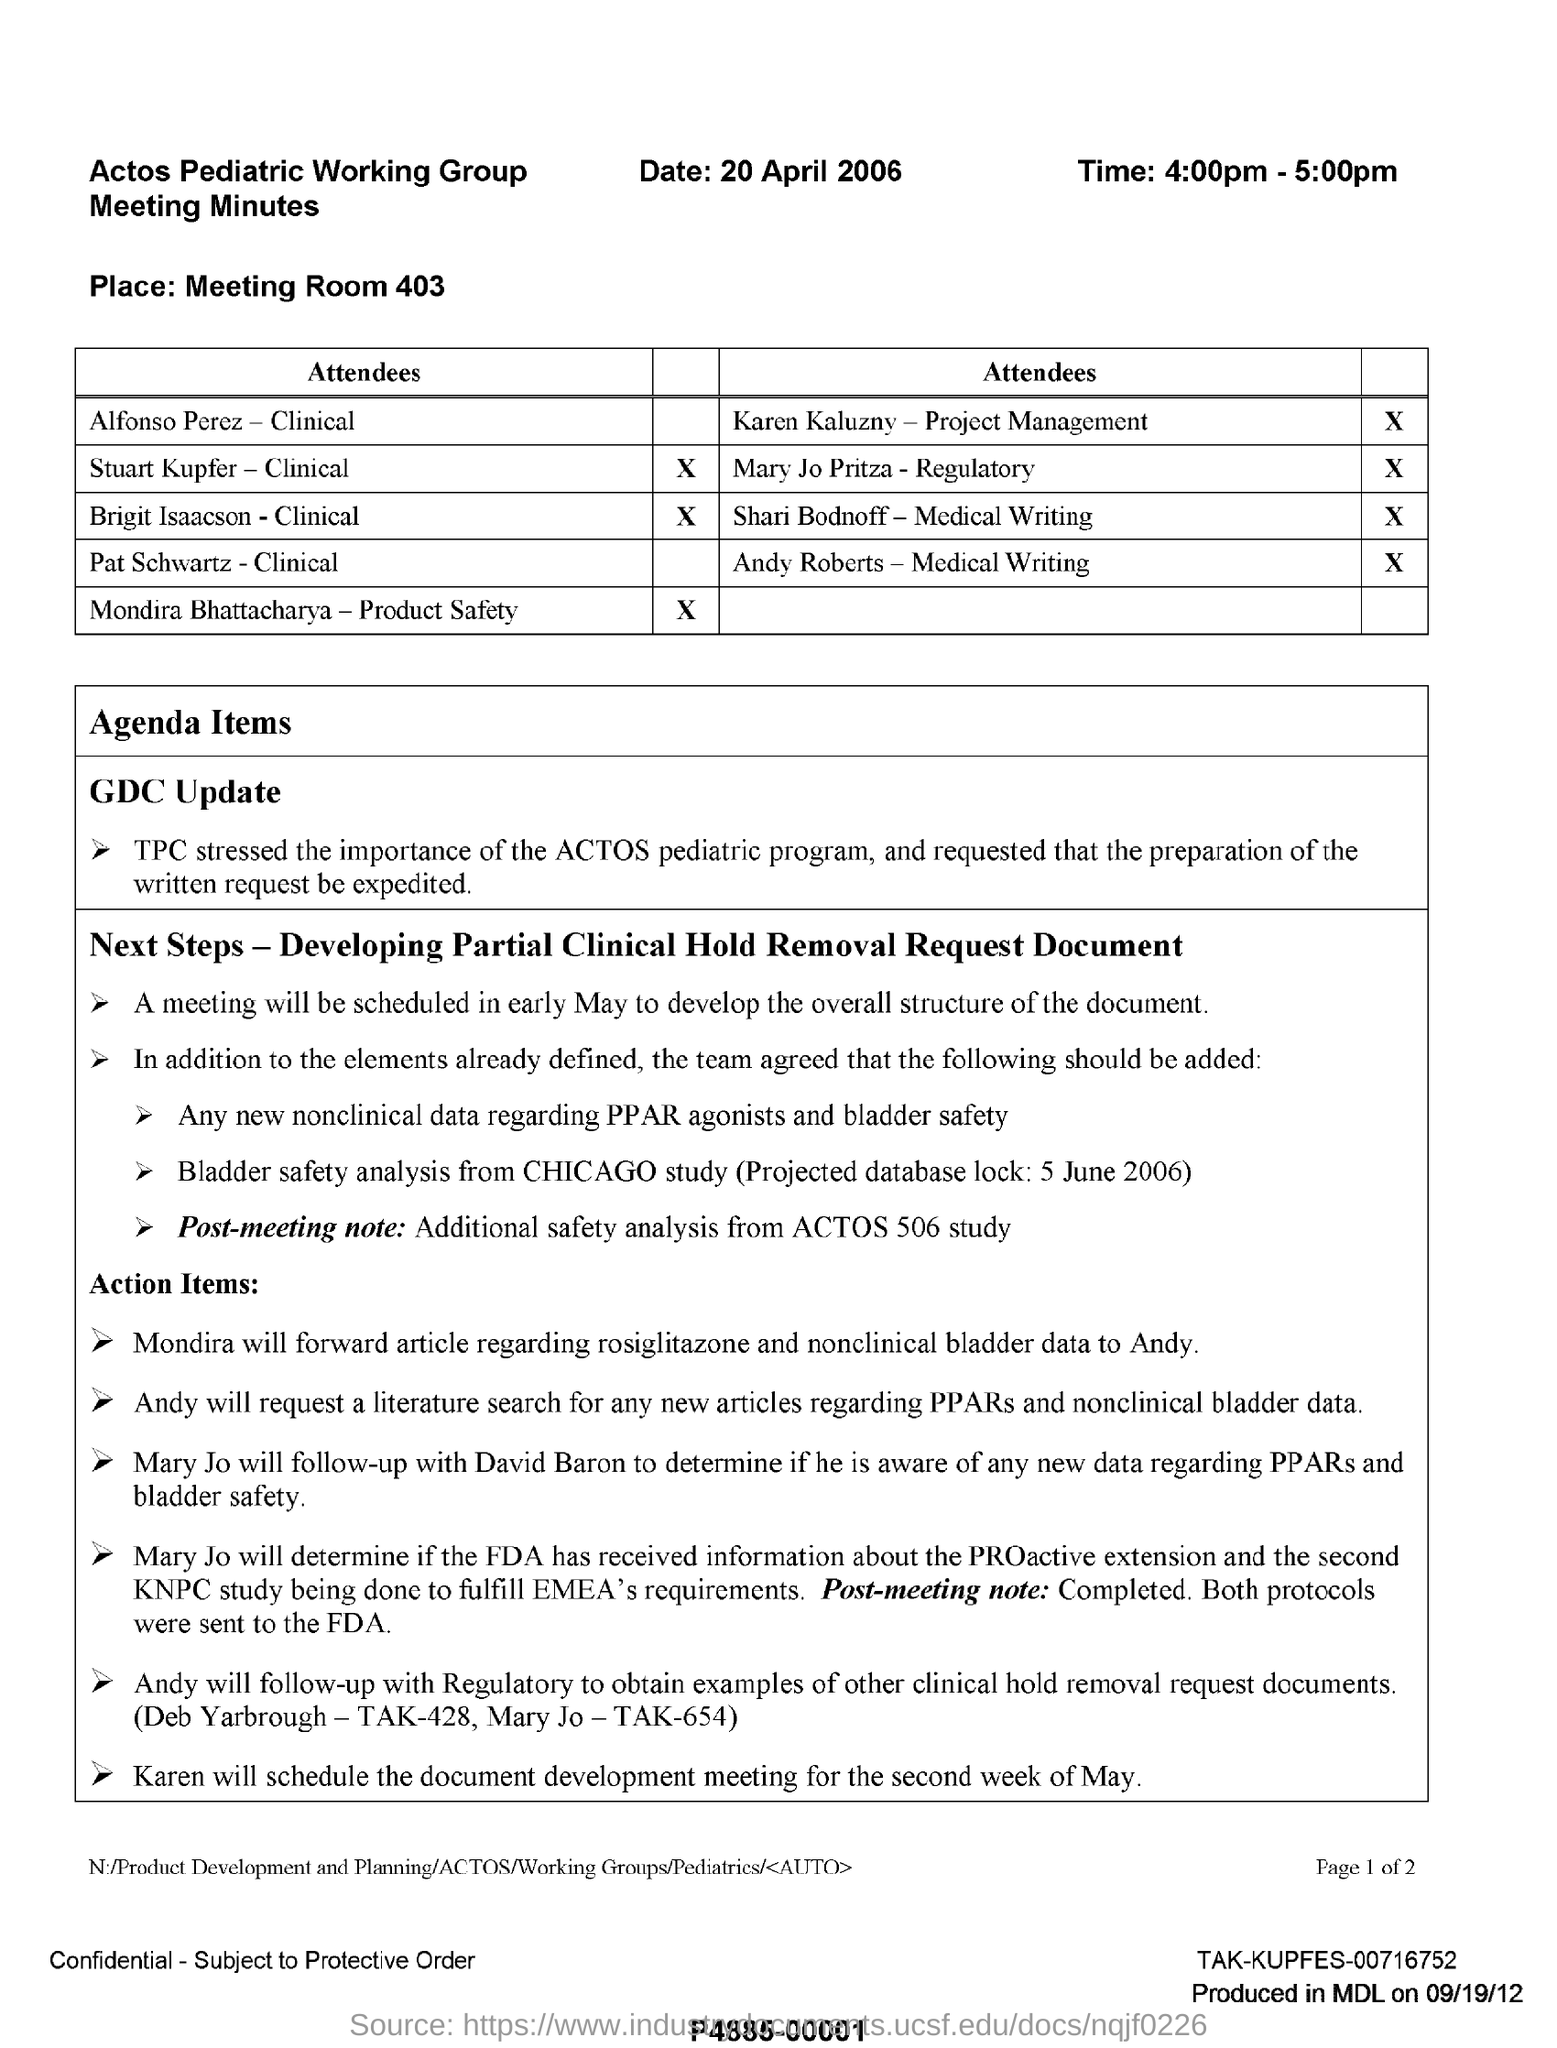What is the date mentioned in the given information ?
Your answer should be very brief. 20 April 2006. What is the meeting time mentioned here?
Offer a terse response. 4:00pm - 5:00pm. What is the place mentioned ?
Make the answer very short. Meeting room 403. Who will forward the article regarding rosiglitazone and non clinical bladder data to andy ?
Your answer should be very brief. Mondira. What date is the meeting scheduled to develop the overall structure of the document?
Make the answer very short. In early may. 